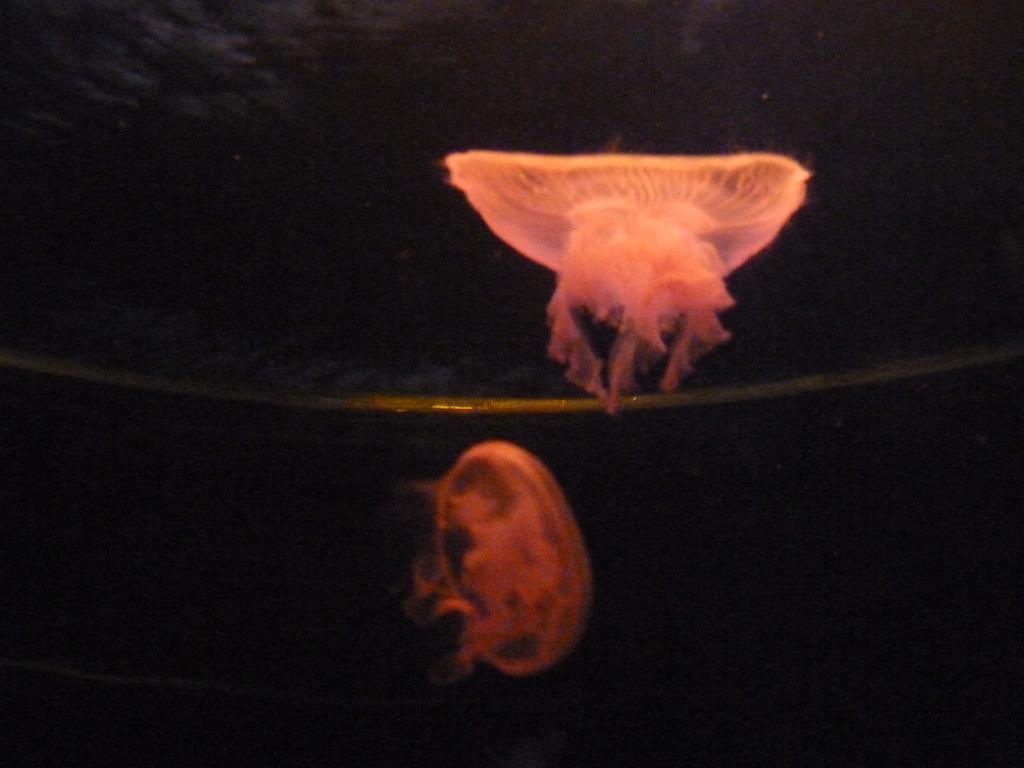Please provide a concise description of this image. In this picture we can see two pink color jellyfish. Behind there is a black background. 